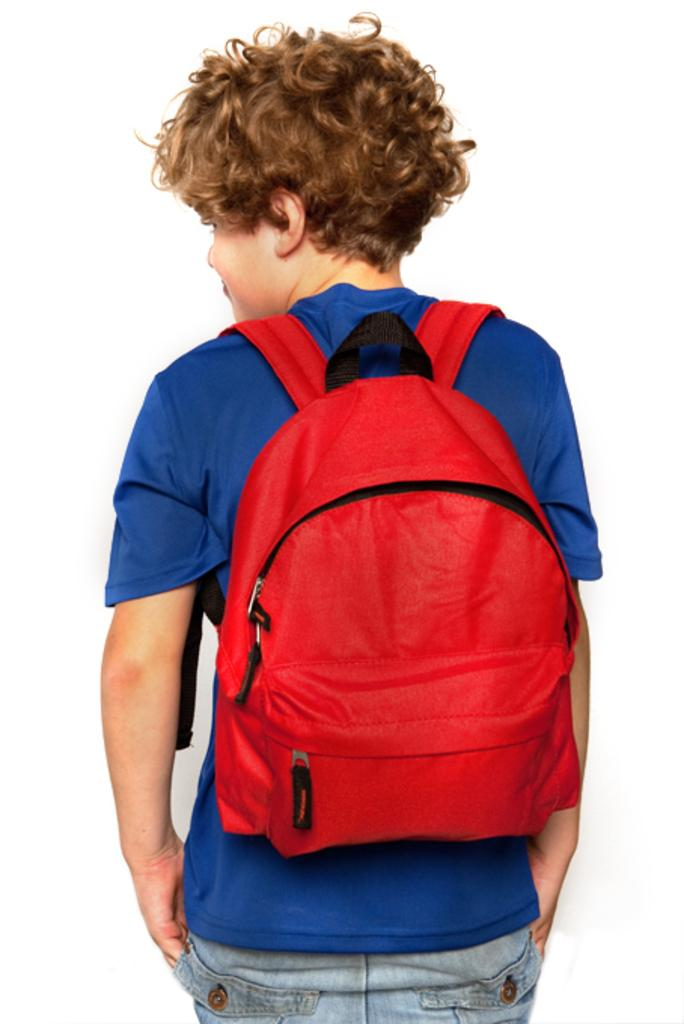Who is the main subject in the image? There is a boy in the image. What is the boy wearing? The boy is wearing a blue T-shirt. What is the boy carrying on his back? The boy is carrying a bag on his back. Where are the geese located in the image? There are no geese present in the image. What type of cloth is draped over the playground in the image? There is no playground or cloth present in the image. 